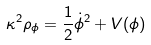<formula> <loc_0><loc_0><loc_500><loc_500>\kappa ^ { 2 } \rho _ { \phi } = \frac { 1 } { 2 } \dot { \phi } ^ { 2 } + V ( \phi )</formula> 